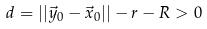<formula> <loc_0><loc_0><loc_500><loc_500>d = | | \vec { y } _ { 0 } - \vec { x } _ { 0 } | | - r - R > 0</formula> 